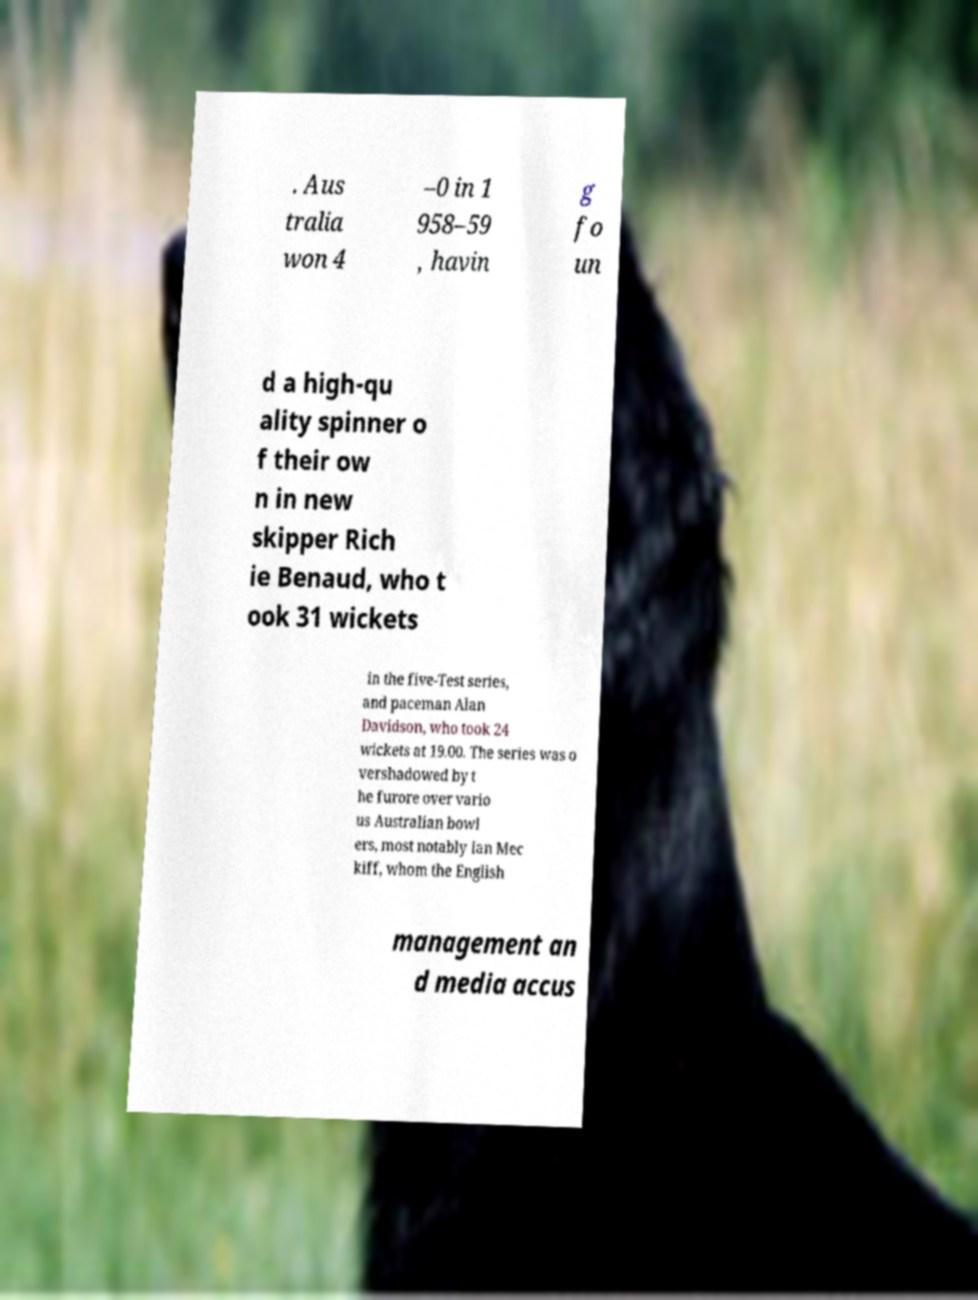What messages or text are displayed in this image? I need them in a readable, typed format. . Aus tralia won 4 –0 in 1 958–59 , havin g fo un d a high-qu ality spinner o f their ow n in new skipper Rich ie Benaud, who t ook 31 wickets in the five-Test series, and paceman Alan Davidson, who took 24 wickets at 19.00. The series was o vershadowed by t he furore over vario us Australian bowl ers, most notably Ian Mec kiff, whom the English management an d media accus 